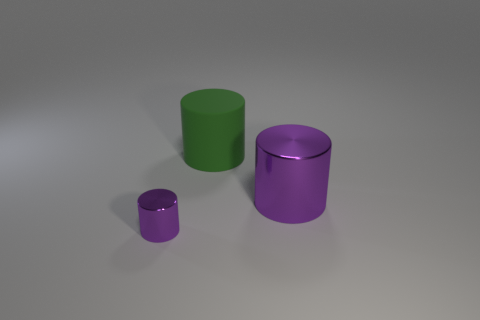What is the size of the matte thing? There are three cylindrical objects, each with a varying size. The largest has a matte purple finish, and according to the relative size comparison in the image, it is significantly larger than the other items and would be classified as large. 